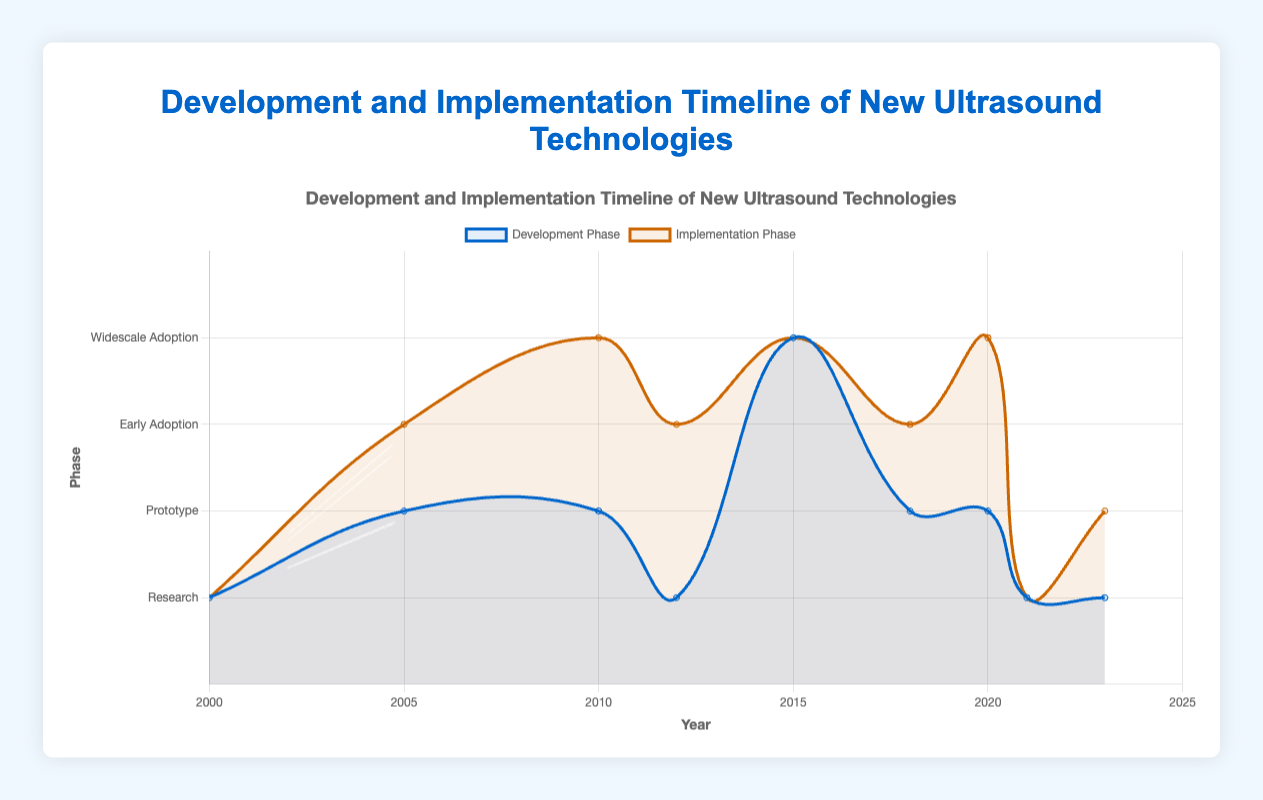Which technology reached "Widescale Adoption" in the implementation phase in 2020? Look at the implementation phase line for the year 2020 and find the technology at the widescale adoption level. The technology is "Handheld Wireless Ultrasound".
Answer: Handheld Wireless Ultrasound How many technologies were in the "Prototype" phase of development in 2018? Refer to the development phase line specifically for 2018 and count the number of technologies in the prototype phase. Only one technology, "AI-enabled Ultrasound," is in the prototype phase.
Answer: 1 What is the difference in years between the first and last recorded technology advancements? Identify the years for the first (2000) and last (2023) technology advancements and calculate the difference: 2023 - 2000.
Answer: 23 years Which technology had the same phase for both development and implementation in 2021? Find the year 2021, and check both the development and implementation phases. "Ultrasound Tomography" has the same phase (Research) for both development and implementation.
Answer: Ultrasound Tomography How many technologies reached "Early Adoption" in the implementation phase by 2023? Identify all data points up to 2023 where the implementation phase is "Early Adoption". There are three technologies: "Portable Ultrasound" (2005), "Automated Breast Ultrasound" (2012), and "AI-enabled Ultrasound" (2018).
Answer: 3 Which technology was in the "Research" phase of development but in the "Early Adoption" phase of implementation in 2012? For the year 2012, check the technology where development is "Research" and implementation is "Early Adoption". That technology is "Automated Breast Ultrasound".
Answer: Automated Breast Ultrasound Which company developed the "Elastography" technology? Look for the technology named "Elastography" in the dataset and note its corresponding company. The company is "Siemens Healthineers".
Answer: Siemens Healthineers What phase was "Contrast-Enhanced Ultrasound" in during its implementation phase in 2015? Locate the year 2015 and identify the phase of "Contrast-Enhanced Ultrasound" in the implementation phase. It is in "Widescale Adoption".
Answer: Widescale Adoption How does the implementation phase of "3D Ultrasound" in 2000 compare with its development phase? Check both development and implementation phases for "3D Ultrasound" in 2000. Both phases are in "Research".
Answer: Both are in Research Which technology jumped from "Prototype" in the development phase to "Widescale Adoption" in the implementation phase in 2010? For the year 2010, look at technologies in the development "Prototype" phase and implementation "Widescale Adoption" phase. The technology is "Elastography".
Answer: Elastography 